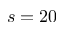<formula> <loc_0><loc_0><loc_500><loc_500>s = 2 0</formula> 